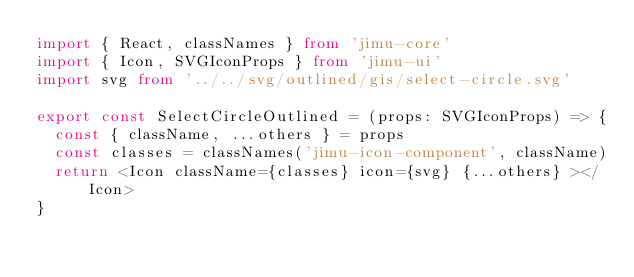Convert code to text. <code><loc_0><loc_0><loc_500><loc_500><_TypeScript_>import { React, classNames } from 'jimu-core'
import { Icon, SVGIconProps } from 'jimu-ui'
import svg from '../../svg/outlined/gis/select-circle.svg'

export const SelectCircleOutlined = (props: SVGIconProps) => {
  const { className, ...others } = props
  const classes = classNames('jimu-icon-component', className)
  return <Icon className={classes} icon={svg} {...others} ></Icon>
}
</code> 